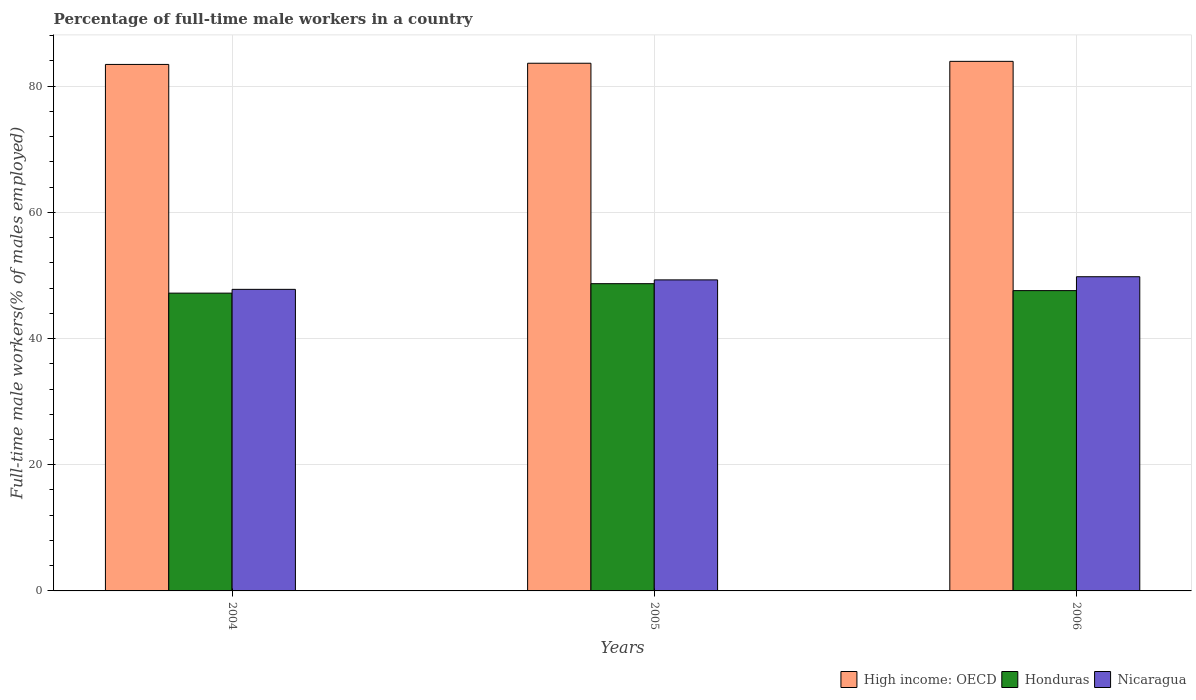Are the number of bars on each tick of the X-axis equal?
Offer a terse response. Yes. How many bars are there on the 2nd tick from the left?
Provide a short and direct response. 3. What is the percentage of full-time male workers in High income: OECD in 2006?
Keep it short and to the point. 83.94. Across all years, what is the maximum percentage of full-time male workers in High income: OECD?
Give a very brief answer. 83.94. Across all years, what is the minimum percentage of full-time male workers in High income: OECD?
Offer a terse response. 83.45. In which year was the percentage of full-time male workers in Honduras minimum?
Keep it short and to the point. 2004. What is the total percentage of full-time male workers in Honduras in the graph?
Provide a short and direct response. 143.5. What is the difference between the percentage of full-time male workers in Honduras in 2005 and that in 2006?
Offer a very short reply. 1.1. What is the difference between the percentage of full-time male workers in Honduras in 2005 and the percentage of full-time male workers in Nicaragua in 2006?
Offer a very short reply. -1.1. What is the average percentage of full-time male workers in High income: OECD per year?
Your response must be concise. 83.68. In the year 2004, what is the difference between the percentage of full-time male workers in High income: OECD and percentage of full-time male workers in Honduras?
Provide a short and direct response. 36.25. What is the ratio of the percentage of full-time male workers in Nicaragua in 2004 to that in 2006?
Provide a short and direct response. 0.96. Is the difference between the percentage of full-time male workers in High income: OECD in 2004 and 2006 greater than the difference between the percentage of full-time male workers in Honduras in 2004 and 2006?
Offer a very short reply. No. What is the difference between the highest and the second highest percentage of full-time male workers in High income: OECD?
Give a very brief answer. 0.3. What does the 3rd bar from the left in 2004 represents?
Offer a terse response. Nicaragua. What does the 2nd bar from the right in 2006 represents?
Provide a succinct answer. Honduras. Is it the case that in every year, the sum of the percentage of full-time male workers in Honduras and percentage of full-time male workers in High income: OECD is greater than the percentage of full-time male workers in Nicaragua?
Offer a terse response. Yes. Are all the bars in the graph horizontal?
Offer a terse response. No. What is the difference between two consecutive major ticks on the Y-axis?
Your answer should be compact. 20. Does the graph contain any zero values?
Provide a short and direct response. No. Does the graph contain grids?
Provide a succinct answer. Yes. How are the legend labels stacked?
Keep it short and to the point. Horizontal. What is the title of the graph?
Ensure brevity in your answer.  Percentage of full-time male workers in a country. Does "Isle of Man" appear as one of the legend labels in the graph?
Keep it short and to the point. No. What is the label or title of the X-axis?
Offer a very short reply. Years. What is the label or title of the Y-axis?
Your answer should be very brief. Full-time male workers(% of males employed). What is the Full-time male workers(% of males employed) of High income: OECD in 2004?
Provide a short and direct response. 83.45. What is the Full-time male workers(% of males employed) in Honduras in 2004?
Provide a succinct answer. 47.2. What is the Full-time male workers(% of males employed) in Nicaragua in 2004?
Provide a short and direct response. 47.8. What is the Full-time male workers(% of males employed) in High income: OECD in 2005?
Your answer should be very brief. 83.64. What is the Full-time male workers(% of males employed) in Honduras in 2005?
Provide a short and direct response. 48.7. What is the Full-time male workers(% of males employed) of Nicaragua in 2005?
Offer a terse response. 49.3. What is the Full-time male workers(% of males employed) of High income: OECD in 2006?
Your answer should be compact. 83.94. What is the Full-time male workers(% of males employed) in Honduras in 2006?
Provide a succinct answer. 47.6. What is the Full-time male workers(% of males employed) in Nicaragua in 2006?
Your answer should be compact. 49.8. Across all years, what is the maximum Full-time male workers(% of males employed) of High income: OECD?
Keep it short and to the point. 83.94. Across all years, what is the maximum Full-time male workers(% of males employed) in Honduras?
Your answer should be compact. 48.7. Across all years, what is the maximum Full-time male workers(% of males employed) of Nicaragua?
Give a very brief answer. 49.8. Across all years, what is the minimum Full-time male workers(% of males employed) in High income: OECD?
Keep it short and to the point. 83.45. Across all years, what is the minimum Full-time male workers(% of males employed) of Honduras?
Give a very brief answer. 47.2. Across all years, what is the minimum Full-time male workers(% of males employed) of Nicaragua?
Offer a very short reply. 47.8. What is the total Full-time male workers(% of males employed) in High income: OECD in the graph?
Your answer should be compact. 251.03. What is the total Full-time male workers(% of males employed) in Honduras in the graph?
Your response must be concise. 143.5. What is the total Full-time male workers(% of males employed) in Nicaragua in the graph?
Your answer should be compact. 146.9. What is the difference between the Full-time male workers(% of males employed) in High income: OECD in 2004 and that in 2005?
Your answer should be compact. -0.19. What is the difference between the Full-time male workers(% of males employed) in High income: OECD in 2004 and that in 2006?
Keep it short and to the point. -0.49. What is the difference between the Full-time male workers(% of males employed) of Nicaragua in 2004 and that in 2006?
Ensure brevity in your answer.  -2. What is the difference between the Full-time male workers(% of males employed) in High income: OECD in 2005 and that in 2006?
Keep it short and to the point. -0.3. What is the difference between the Full-time male workers(% of males employed) in High income: OECD in 2004 and the Full-time male workers(% of males employed) in Honduras in 2005?
Your response must be concise. 34.75. What is the difference between the Full-time male workers(% of males employed) in High income: OECD in 2004 and the Full-time male workers(% of males employed) in Nicaragua in 2005?
Offer a very short reply. 34.15. What is the difference between the Full-time male workers(% of males employed) in Honduras in 2004 and the Full-time male workers(% of males employed) in Nicaragua in 2005?
Your answer should be very brief. -2.1. What is the difference between the Full-time male workers(% of males employed) in High income: OECD in 2004 and the Full-time male workers(% of males employed) in Honduras in 2006?
Your answer should be compact. 35.85. What is the difference between the Full-time male workers(% of males employed) of High income: OECD in 2004 and the Full-time male workers(% of males employed) of Nicaragua in 2006?
Give a very brief answer. 33.65. What is the difference between the Full-time male workers(% of males employed) in High income: OECD in 2005 and the Full-time male workers(% of males employed) in Honduras in 2006?
Keep it short and to the point. 36.04. What is the difference between the Full-time male workers(% of males employed) of High income: OECD in 2005 and the Full-time male workers(% of males employed) of Nicaragua in 2006?
Give a very brief answer. 33.84. What is the average Full-time male workers(% of males employed) in High income: OECD per year?
Offer a terse response. 83.68. What is the average Full-time male workers(% of males employed) in Honduras per year?
Your answer should be compact. 47.83. What is the average Full-time male workers(% of males employed) in Nicaragua per year?
Your answer should be very brief. 48.97. In the year 2004, what is the difference between the Full-time male workers(% of males employed) in High income: OECD and Full-time male workers(% of males employed) in Honduras?
Provide a short and direct response. 36.25. In the year 2004, what is the difference between the Full-time male workers(% of males employed) in High income: OECD and Full-time male workers(% of males employed) in Nicaragua?
Your answer should be very brief. 35.65. In the year 2004, what is the difference between the Full-time male workers(% of males employed) in Honduras and Full-time male workers(% of males employed) in Nicaragua?
Ensure brevity in your answer.  -0.6. In the year 2005, what is the difference between the Full-time male workers(% of males employed) in High income: OECD and Full-time male workers(% of males employed) in Honduras?
Offer a terse response. 34.94. In the year 2005, what is the difference between the Full-time male workers(% of males employed) in High income: OECD and Full-time male workers(% of males employed) in Nicaragua?
Provide a succinct answer. 34.34. In the year 2006, what is the difference between the Full-time male workers(% of males employed) of High income: OECD and Full-time male workers(% of males employed) of Honduras?
Provide a short and direct response. 36.34. In the year 2006, what is the difference between the Full-time male workers(% of males employed) of High income: OECD and Full-time male workers(% of males employed) of Nicaragua?
Give a very brief answer. 34.14. In the year 2006, what is the difference between the Full-time male workers(% of males employed) of Honduras and Full-time male workers(% of males employed) of Nicaragua?
Your answer should be compact. -2.2. What is the ratio of the Full-time male workers(% of males employed) of Honduras in 2004 to that in 2005?
Your response must be concise. 0.97. What is the ratio of the Full-time male workers(% of males employed) of Nicaragua in 2004 to that in 2005?
Keep it short and to the point. 0.97. What is the ratio of the Full-time male workers(% of males employed) of High income: OECD in 2004 to that in 2006?
Ensure brevity in your answer.  0.99. What is the ratio of the Full-time male workers(% of males employed) in Nicaragua in 2004 to that in 2006?
Your answer should be very brief. 0.96. What is the ratio of the Full-time male workers(% of males employed) in Honduras in 2005 to that in 2006?
Provide a short and direct response. 1.02. What is the ratio of the Full-time male workers(% of males employed) in Nicaragua in 2005 to that in 2006?
Make the answer very short. 0.99. What is the difference between the highest and the second highest Full-time male workers(% of males employed) of High income: OECD?
Offer a terse response. 0.3. What is the difference between the highest and the second highest Full-time male workers(% of males employed) in Honduras?
Keep it short and to the point. 1.1. What is the difference between the highest and the second highest Full-time male workers(% of males employed) in Nicaragua?
Your answer should be compact. 0.5. What is the difference between the highest and the lowest Full-time male workers(% of males employed) in High income: OECD?
Your answer should be very brief. 0.49. What is the difference between the highest and the lowest Full-time male workers(% of males employed) in Honduras?
Your answer should be compact. 1.5. 